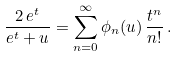Convert formula to latex. <formula><loc_0><loc_0><loc_500><loc_500>\frac { 2 \, e ^ { t } } { e ^ { t } + u } = \sum _ { n = 0 } ^ { \infty } { \phi _ { n } ( u ) \, \frac { t ^ { n } } { n ! } } \, .</formula> 